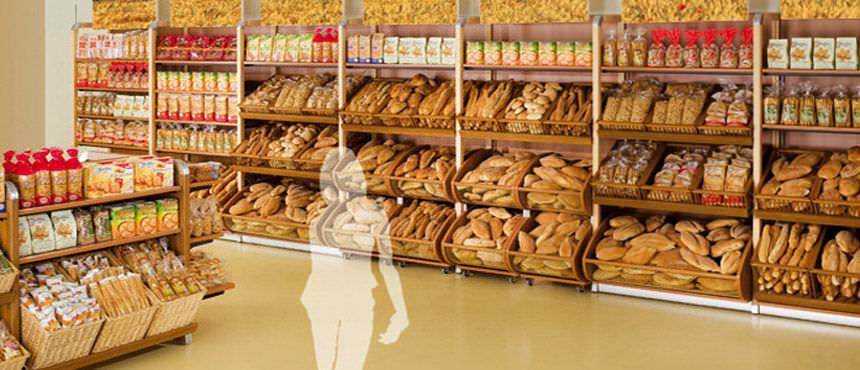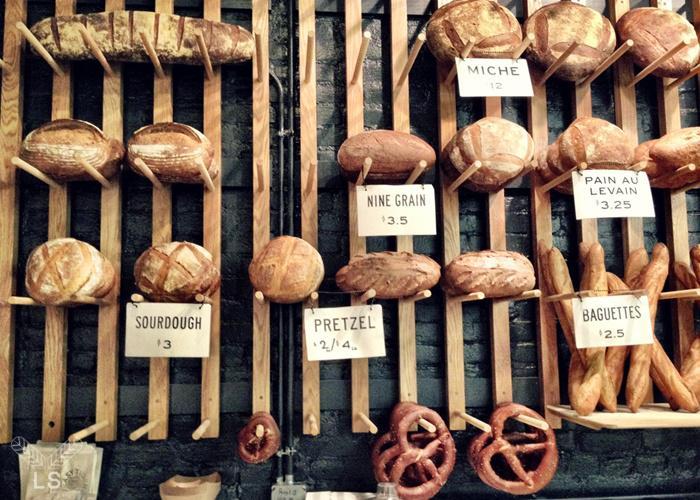The first image is the image on the left, the second image is the image on the right. Considering the images on both sides, is "Both images contain labels and prices." valid? Answer yes or no. No. 